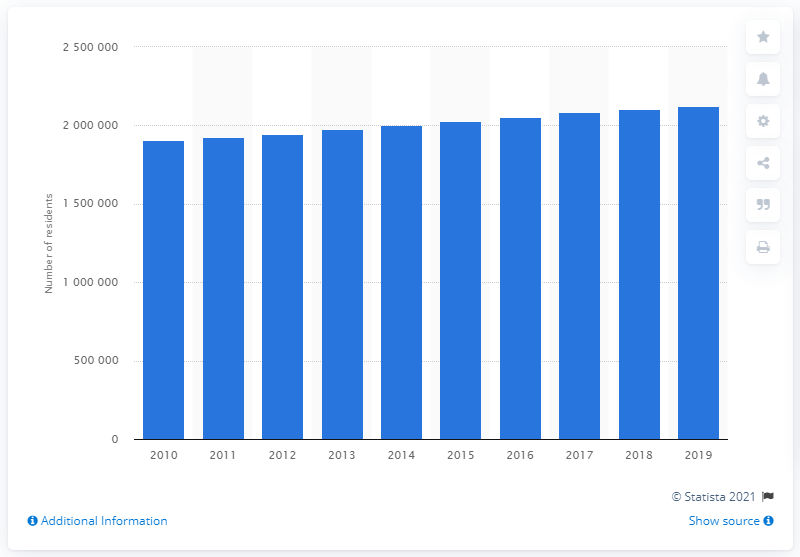Highlight a few significant elements in this photo. According to the data provided, in 2019, there were 2,104,194 individuals living in the Columbus metropolitan area. 